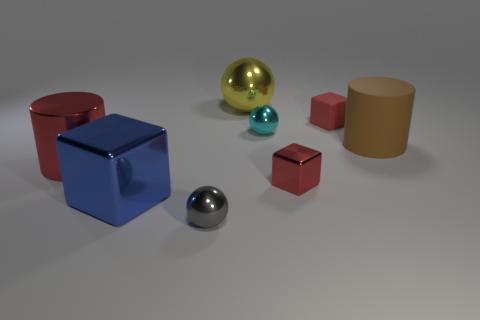Do the objects appear to be arranged in any particular pattern? The objects are scattered and don't seem to follow a specific pattern. They are spaced apart randomly on a smooth surface, creating an interesting mix of shapes and colors without any apparent order. 